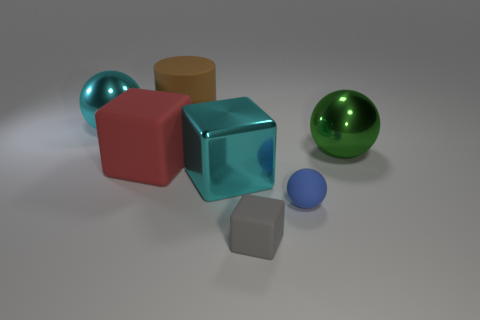Subtract all cyan blocks. How many blocks are left? 2 Subtract all cylinders. How many objects are left? 6 Subtract 1 cubes. How many cubes are left? 2 Subtract all gray balls. Subtract all green cylinders. How many balls are left? 3 Subtract all yellow cylinders. How many brown spheres are left? 0 Subtract all gray shiny spheres. Subtract all large shiny things. How many objects are left? 4 Add 4 cyan cubes. How many cyan cubes are left? 5 Add 7 tiny red shiny cylinders. How many tiny red shiny cylinders exist? 7 Add 2 big brown rubber objects. How many objects exist? 9 Subtract 0 green blocks. How many objects are left? 7 